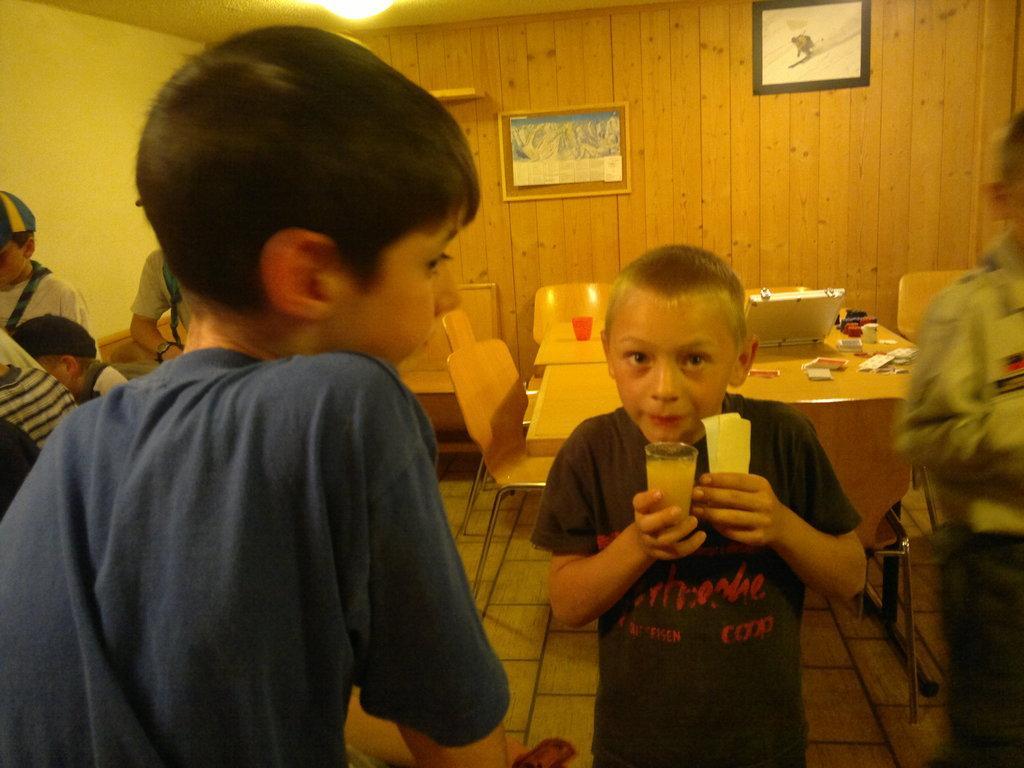Describe this image in one or two sentences. On the left side, there is a boy in a T-shirt. Beside him, there is a boy in a T-shirt, holding a glass with one hand, holding an object with the other hand and standing. In the background, there are other children, there are chairs arranged around a table , on which there are some objects, there are photo frames on a wooden wall and there is a light attached to the roof. 